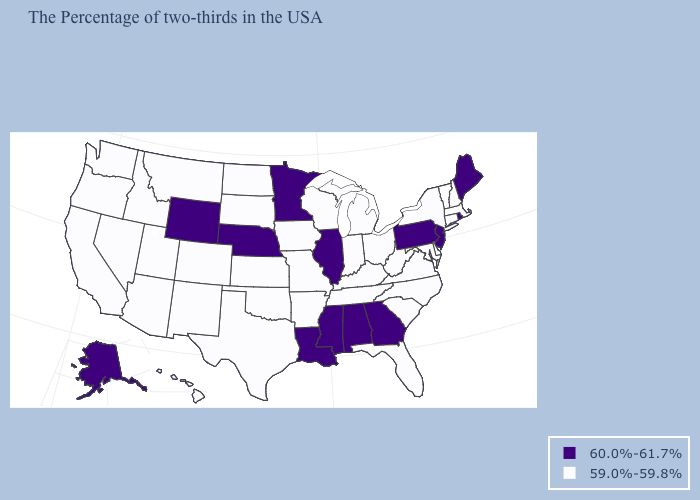Does South Carolina have a lower value than Wyoming?
Quick response, please. Yes. What is the value of Rhode Island?
Short answer required. 60.0%-61.7%. Does the first symbol in the legend represent the smallest category?
Give a very brief answer. No. What is the lowest value in the USA?
Answer briefly. 59.0%-59.8%. What is the value of Oregon?
Concise answer only. 59.0%-59.8%. Name the states that have a value in the range 60.0%-61.7%?
Give a very brief answer. Maine, Rhode Island, New Jersey, Pennsylvania, Georgia, Alabama, Illinois, Mississippi, Louisiana, Minnesota, Nebraska, Wyoming, Alaska. Name the states that have a value in the range 60.0%-61.7%?
Give a very brief answer. Maine, Rhode Island, New Jersey, Pennsylvania, Georgia, Alabama, Illinois, Mississippi, Louisiana, Minnesota, Nebraska, Wyoming, Alaska. Among the states that border Florida , which have the lowest value?
Answer briefly. Georgia, Alabama. Name the states that have a value in the range 60.0%-61.7%?
Give a very brief answer. Maine, Rhode Island, New Jersey, Pennsylvania, Georgia, Alabama, Illinois, Mississippi, Louisiana, Minnesota, Nebraska, Wyoming, Alaska. What is the value of North Carolina?
Give a very brief answer. 59.0%-59.8%. Does Wyoming have the lowest value in the USA?
Keep it brief. No. Name the states that have a value in the range 60.0%-61.7%?
Be succinct. Maine, Rhode Island, New Jersey, Pennsylvania, Georgia, Alabama, Illinois, Mississippi, Louisiana, Minnesota, Nebraska, Wyoming, Alaska. Among the states that border South Carolina , which have the lowest value?
Concise answer only. North Carolina. What is the value of Utah?
Keep it brief. 59.0%-59.8%. What is the lowest value in the USA?
Write a very short answer. 59.0%-59.8%. 